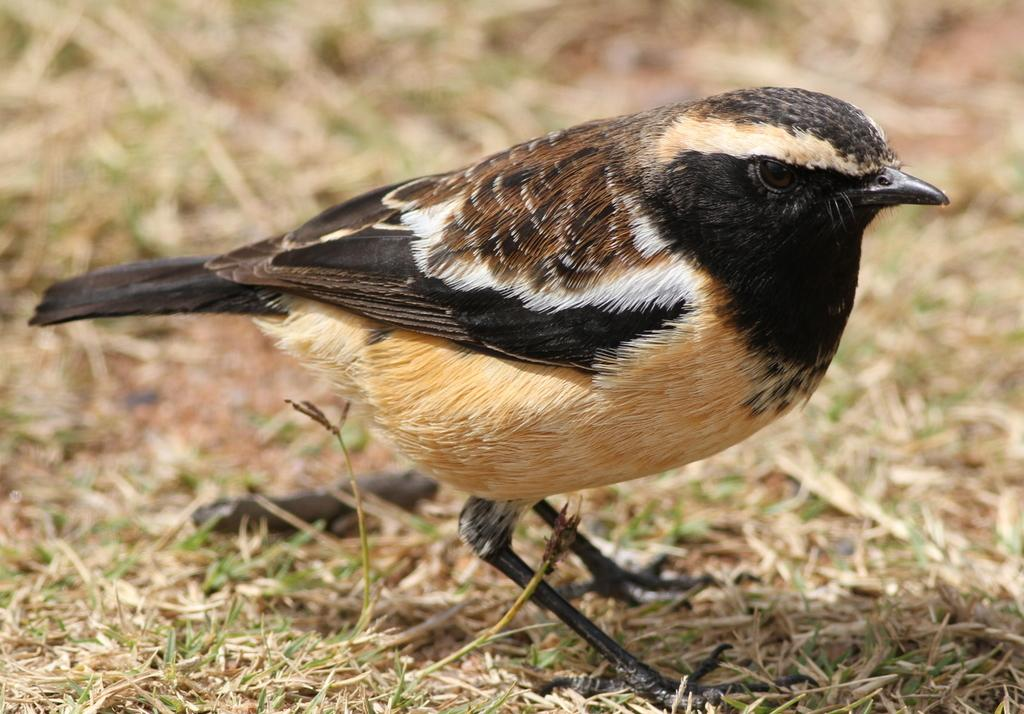What type of animal can be seen in the image? There is a bird in the image. Where is the bird located in the image? The bird is standing on the ground. What is the ground covered with in the image? The ground is covered with dry grass. What type of mine can be seen in the image? There is no mine present in the image; it features a bird standing on the ground covered with dry grass. What level of difficulty is the bird facing in the image? The bird is not facing any level of difficulty in the image; it is simply standing on the ground. 